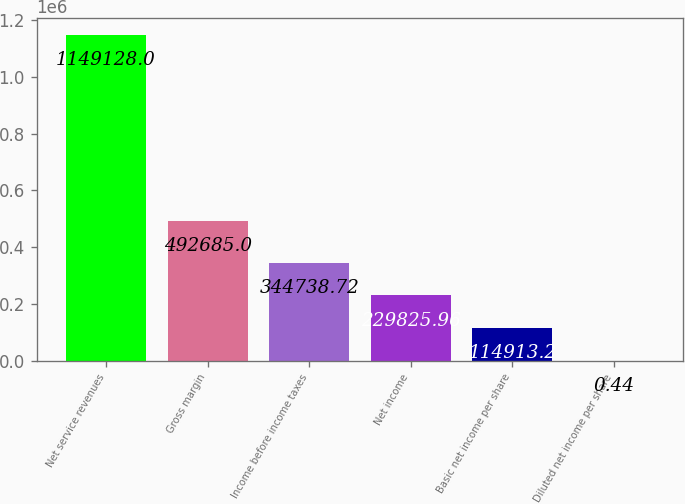<chart> <loc_0><loc_0><loc_500><loc_500><bar_chart><fcel>Net service revenues<fcel>Gross margin<fcel>Income before income taxes<fcel>Net income<fcel>Basic net income per share<fcel>Diluted net income per share<nl><fcel>1.14913e+06<fcel>492685<fcel>344739<fcel>229826<fcel>114913<fcel>0.44<nl></chart> 